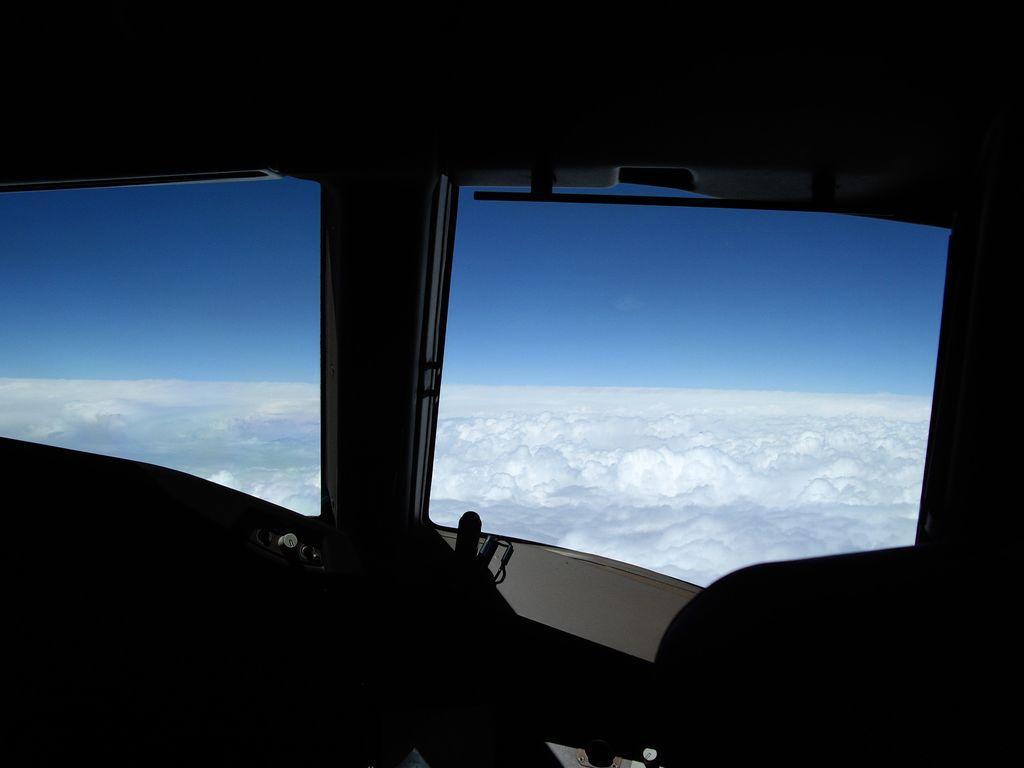Please provide a concise description of this image. This is an inside view of an airplane. At the bottom, I can see few objects in the dark. In the middle of the image there are two window glasses through which we can see the outside view. In the outside, I can see the clouds and sky. 